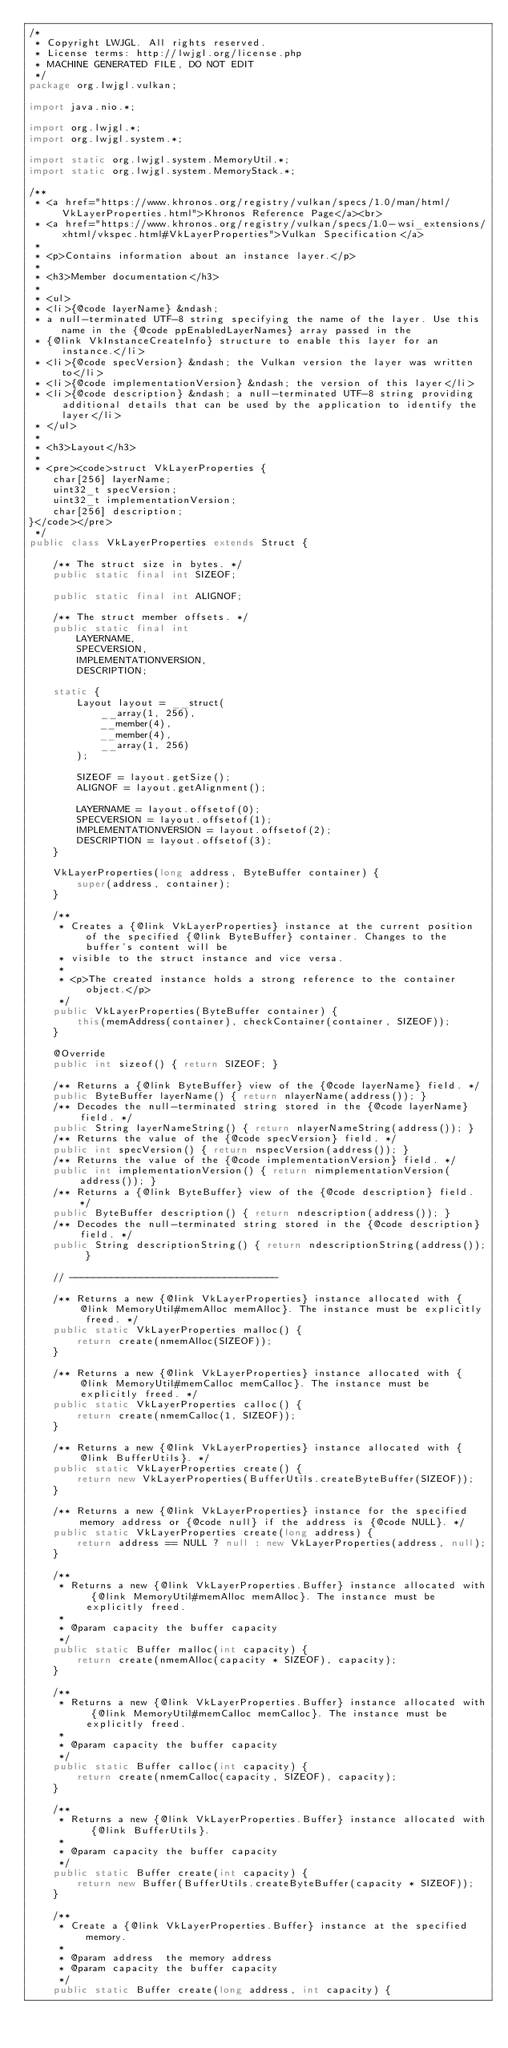<code> <loc_0><loc_0><loc_500><loc_500><_Java_>/*
 * Copyright LWJGL. All rights reserved.
 * License terms: http://lwjgl.org/license.php
 * MACHINE GENERATED FILE, DO NOT EDIT
 */
package org.lwjgl.vulkan;

import java.nio.*;

import org.lwjgl.*;
import org.lwjgl.system.*;

import static org.lwjgl.system.MemoryUtil.*;
import static org.lwjgl.system.MemoryStack.*;

/**
 * <a href="https://www.khronos.org/registry/vulkan/specs/1.0/man/html/VkLayerProperties.html">Khronos Reference Page</a><br>
 * <a href="https://www.khronos.org/registry/vulkan/specs/1.0-wsi_extensions/xhtml/vkspec.html#VkLayerProperties">Vulkan Specification</a>
 * 
 * <p>Contains information about an instance layer.</p>
 * 
 * <h3>Member documentation</h3>
 * 
 * <ul>
 * <li>{@code layerName} &ndash; 
 * a null-terminated UTF-8 string specifying the name of the layer. Use this name in the {@code ppEnabledLayerNames} array passed in the
 * {@link VkInstanceCreateInfo} structure to enable this layer for an instance.</li>
 * <li>{@code specVersion} &ndash; the Vulkan version the layer was written to</li>
 * <li>{@code implementationVersion} &ndash; the version of this layer</li>
 * <li>{@code description} &ndash; a null-terminated UTF-8 string providing additional details that can be used by the application to identify the layer</li>
 * </ul>
 * 
 * <h3>Layout</h3>
 * 
 * <pre><code>struct VkLayerProperties {
    char[256] layerName;
    uint32_t specVersion;
    uint32_t implementationVersion;
    char[256] description;
}</code></pre>
 */
public class VkLayerProperties extends Struct {

	/** The struct size in bytes. */
	public static final int SIZEOF;

	public static final int ALIGNOF;

	/** The struct member offsets. */
	public static final int
		LAYERNAME,
		SPECVERSION,
		IMPLEMENTATIONVERSION,
		DESCRIPTION;

	static {
		Layout layout = __struct(
			__array(1, 256),
			__member(4),
			__member(4),
			__array(1, 256)
		);

		SIZEOF = layout.getSize();
		ALIGNOF = layout.getAlignment();

		LAYERNAME = layout.offsetof(0);
		SPECVERSION = layout.offsetof(1);
		IMPLEMENTATIONVERSION = layout.offsetof(2);
		DESCRIPTION = layout.offsetof(3);
	}

	VkLayerProperties(long address, ByteBuffer container) {
		super(address, container);
	}

	/**
	 * Creates a {@link VkLayerProperties} instance at the current position of the specified {@link ByteBuffer} container. Changes to the buffer's content will be
	 * visible to the struct instance and vice versa.
	 *
	 * <p>The created instance holds a strong reference to the container object.</p>
	 */
	public VkLayerProperties(ByteBuffer container) {
		this(memAddress(container), checkContainer(container, SIZEOF));
	}

	@Override
	public int sizeof() { return SIZEOF; }

	/** Returns a {@link ByteBuffer} view of the {@code layerName} field. */
	public ByteBuffer layerName() { return nlayerName(address()); }
	/** Decodes the null-terminated string stored in the {@code layerName} field. */
	public String layerNameString() { return nlayerNameString(address()); }
	/** Returns the value of the {@code specVersion} field. */
	public int specVersion() { return nspecVersion(address()); }
	/** Returns the value of the {@code implementationVersion} field. */
	public int implementationVersion() { return nimplementationVersion(address()); }
	/** Returns a {@link ByteBuffer} view of the {@code description} field. */
	public ByteBuffer description() { return ndescription(address()); }
	/** Decodes the null-terminated string stored in the {@code description} field. */
	public String descriptionString() { return ndescriptionString(address()); }

	// -----------------------------------

	/** Returns a new {@link VkLayerProperties} instance allocated with {@link MemoryUtil#memAlloc memAlloc}. The instance must be explicitly freed. */
	public static VkLayerProperties malloc() {
		return create(nmemAlloc(SIZEOF));
	}

	/** Returns a new {@link VkLayerProperties} instance allocated with {@link MemoryUtil#memCalloc memCalloc}. The instance must be explicitly freed. */
	public static VkLayerProperties calloc() {
		return create(nmemCalloc(1, SIZEOF));
	}

	/** Returns a new {@link VkLayerProperties} instance allocated with {@link BufferUtils}. */
	public static VkLayerProperties create() {
		return new VkLayerProperties(BufferUtils.createByteBuffer(SIZEOF));
	}

	/** Returns a new {@link VkLayerProperties} instance for the specified memory address or {@code null} if the address is {@code NULL}. */
	public static VkLayerProperties create(long address) {
		return address == NULL ? null : new VkLayerProperties(address, null);
	}

	/**
	 * Returns a new {@link VkLayerProperties.Buffer} instance allocated with {@link MemoryUtil#memAlloc memAlloc}. The instance must be explicitly freed.
	 *
	 * @param capacity the buffer capacity
	 */
	public static Buffer malloc(int capacity) {
		return create(nmemAlloc(capacity * SIZEOF), capacity);
	}

	/**
	 * Returns a new {@link VkLayerProperties.Buffer} instance allocated with {@link MemoryUtil#memCalloc memCalloc}. The instance must be explicitly freed.
	 *
	 * @param capacity the buffer capacity
	 */
	public static Buffer calloc(int capacity) {
		return create(nmemCalloc(capacity, SIZEOF), capacity);
	}

	/**
	 * Returns a new {@link VkLayerProperties.Buffer} instance allocated with {@link BufferUtils}.
	 *
	 * @param capacity the buffer capacity
	 */
	public static Buffer create(int capacity) {
		return new Buffer(BufferUtils.createByteBuffer(capacity * SIZEOF));
	}

	/**
	 * Create a {@link VkLayerProperties.Buffer} instance at the specified memory.
	 *
	 * @param address  the memory address
	 * @param capacity the buffer capacity
	 */
	public static Buffer create(long address, int capacity) {</code> 